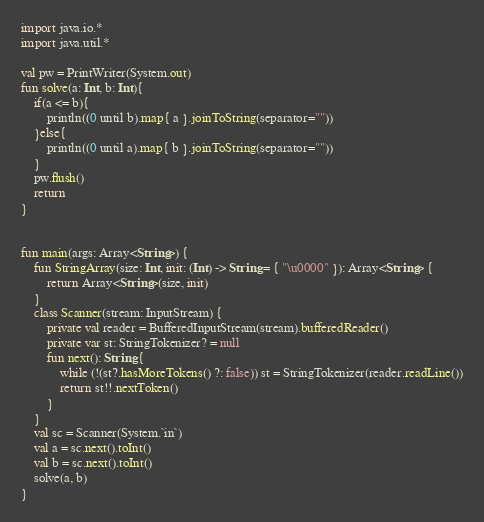<code> <loc_0><loc_0><loc_500><loc_500><_Kotlin_>import java.io.*
import java.util.*

val pw = PrintWriter(System.out)
fun solve(a: Int, b: Int){
    if(a <= b){
        println((0 until b).map{ a }.joinToString(separator=""))
    }else{
        println((0 until a).map{ b }.joinToString(separator=""))
    }
    pw.flush()
    return
}


fun main(args: Array<String>) {
    fun StringArray(size: Int, init: (Int) -> String = { "\u0000" }): Array<String> {
        return Array<String>(size, init)
    }
    class Scanner(stream: InputStream) {
        private val reader = BufferedInputStream(stream).bufferedReader()
        private var st: StringTokenizer? = null
        fun next(): String {
            while (!(st?.hasMoreTokens() ?: false)) st = StringTokenizer(reader.readLine())
            return st!!.nextToken()
        }
    }
    val sc = Scanner(System.`in`)
    val a = sc.next().toInt()
    val b = sc.next().toInt()
    solve(a, b)
}

</code> 